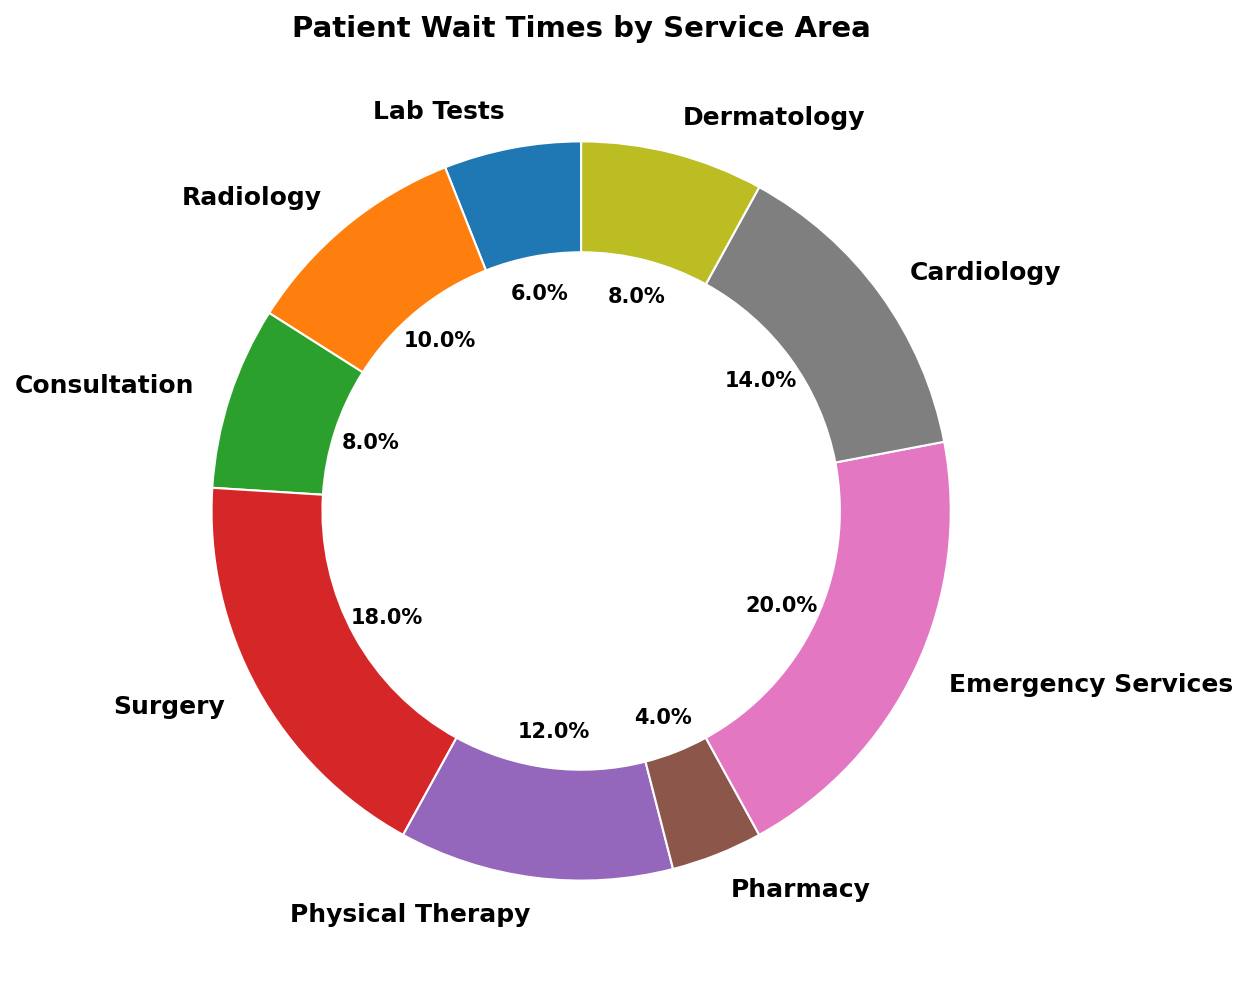Which service area has the longest wait time? Look for the segment representing the longest wait time in the chart. Emergency Services has the longest wait time at 50 minutes.
Answer: Emergency Services Which service area has the shortest wait time? Find the segment with the smallest labeled wait time. Pharmacy has the shortest wait time with 10 minutes.
Answer: Pharmacy What is the combined wait time for Consultation and Dermatology? Add the wait times for Consultation and Dermatology: 20 minutes (Consultation) + 20 minutes (Dermatology) = 40 minutes.
Answer: 40 minutes How does the wait time for Cardiology compare to that of Radiology? Compare the wait times directly: Cardiology is 35 minutes while Radiology is 25 minutes. Cardiology has a longer wait time than Radiology.
Answer: Cardiology has a longer wait time By how many minutes does Surgery exceed Lab Tests in wait time? Subtract the wait time of Lab Tests from Surgery: 45 minutes (Surgery) - 15 minutes (Lab Tests) = 30 minutes.
Answer: 30 minutes What is the average wait time across all service areas? Sum all wait times and divide by the number of service areas: (15 + 25 + 20 + 45 + 30 + 10 + 50 + 35 + 20) / 9 = 250 / 9 ≈ 27.8 minutes.
Answer: ~27.8 minutes What percentage of the total wait time is spent on Emergency Services? Find the wait time for Emergency Services, and calculate the percentage of the total wait time: 50 / (15 + 25 + 20 + 45 + 30 + 10 + 50 + 35 + 20) ≈ 0.20.
Answer: ~20% Which three service areas have the highest wait times? Identify the segments with the three largest wait times: Emergency Services (50 minutes), Surgery (45 minutes), and Cardiology (35 minutes).
Answer: Emergency Services, Surgery, Cardiology What is the total wait time for all specified services? Sum all wait times: 15 + 25 + 20 + 45 + 30 + 10 + 50 + 35 + 20 = 250 minutes.
Answer: 250 minutes 